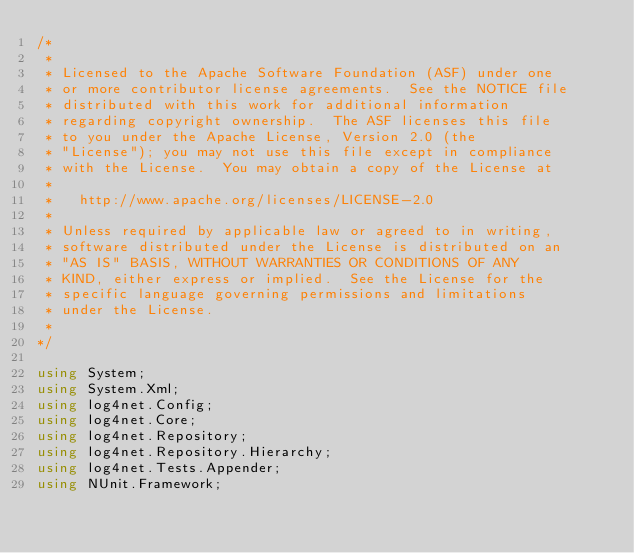Convert code to text. <code><loc_0><loc_0><loc_500><loc_500><_C#_>/*
 *
 * Licensed to the Apache Software Foundation (ASF) under one
 * or more contributor license agreements.  See the NOTICE file
 * distributed with this work for additional information
 * regarding copyright ownership.  The ASF licenses this file
 * to you under the Apache License, Version 2.0 (the
 * "License"); you may not use this file except in compliance
 * with the License.  You may obtain a copy of the License at
 *
 *   http://www.apache.org/licenses/LICENSE-2.0
 *
 * Unless required by applicable law or agreed to in writing,
 * software distributed under the License is distributed on an
 * "AS IS" BASIS, WITHOUT WARRANTIES OR CONDITIONS OF ANY
 * KIND, either express or implied.  See the License for the
 * specific language governing permissions and limitations
 * under the License.
 *
*/

using System;
using System.Xml;
using log4net.Config;
using log4net.Core;
using log4net.Repository;
using log4net.Repository.Hierarchy;
using log4net.Tests.Appender;
using NUnit.Framework;
</code> 